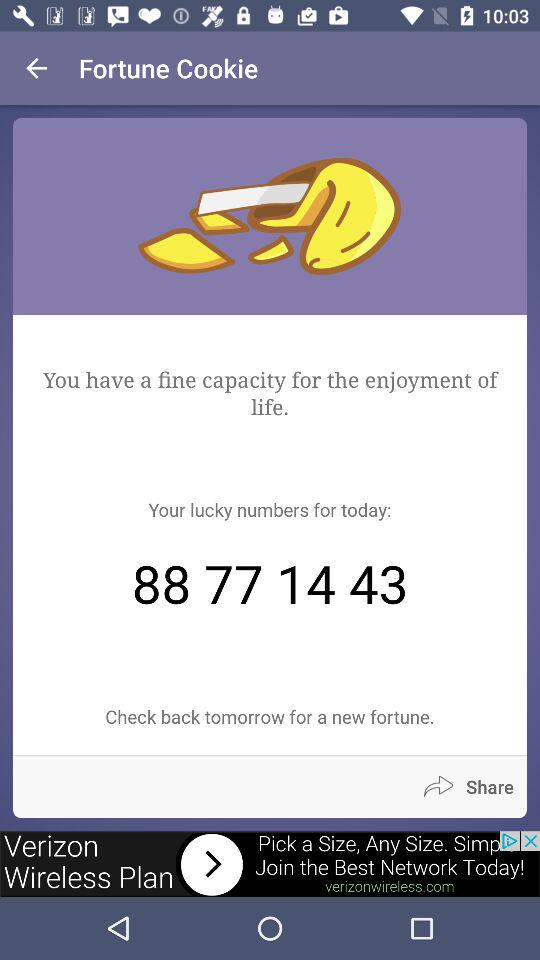What is the lucky number? The lucky numbers are 88, 77, 14 and 43. 